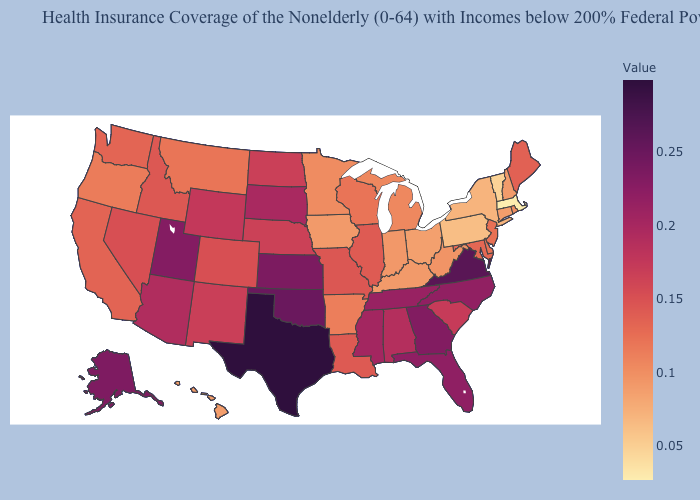Does Florida have the highest value in the South?
Give a very brief answer. No. Does Maine have a higher value than Rhode Island?
Quick response, please. Yes. Is the legend a continuous bar?
Be succinct. Yes. Which states hav the highest value in the MidWest?
Short answer required. Kansas. Does Kentucky have the lowest value in the South?
Short answer required. Yes. Which states hav the highest value in the West?
Short answer required. Alaska. 